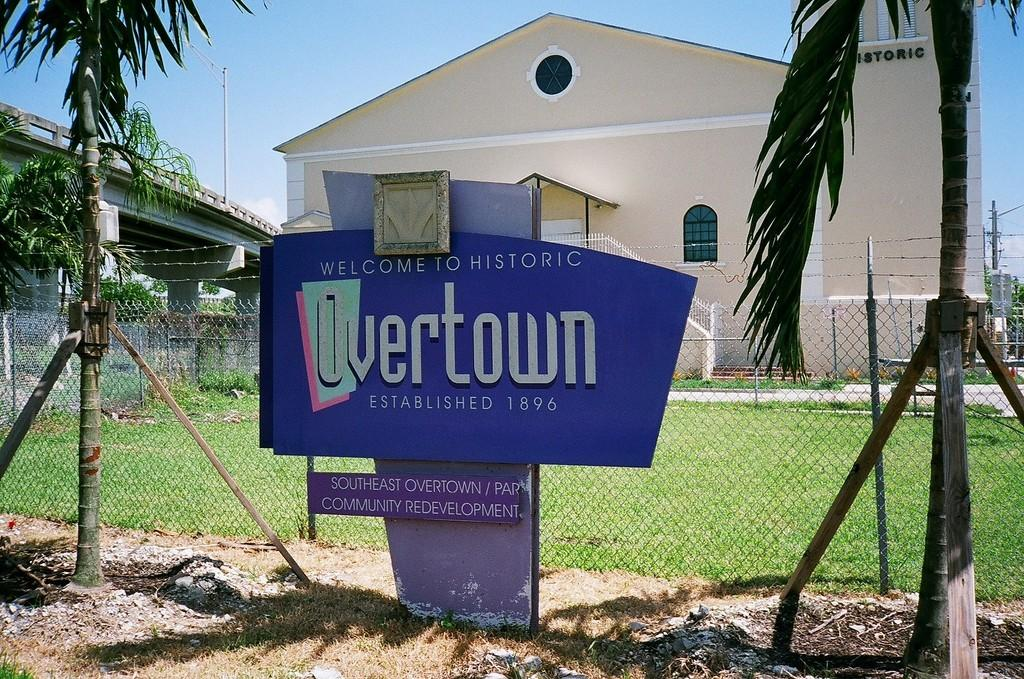What type of structure is visible in the image? There is a house in the image. What features can be observed on the house? The house has windows and stairs. What other objects or elements can be seen in the image? There are trees, net fencing, boards, current poles, wires, a bridge, and green grass in the image. How is the sky depicted in the image? The sky is in white and blue color. Can you tell me how many berries are hanging from the current poles in the image? There are no berries present in the image, as it features a house, trees, net fencing, boards, current poles, wires, a bridge, and green grass. Is there a knot tied on the bridge in the image? There is no mention of a knot or any specific details about the bridge in the image, so it cannot be determined from the provided facts. 